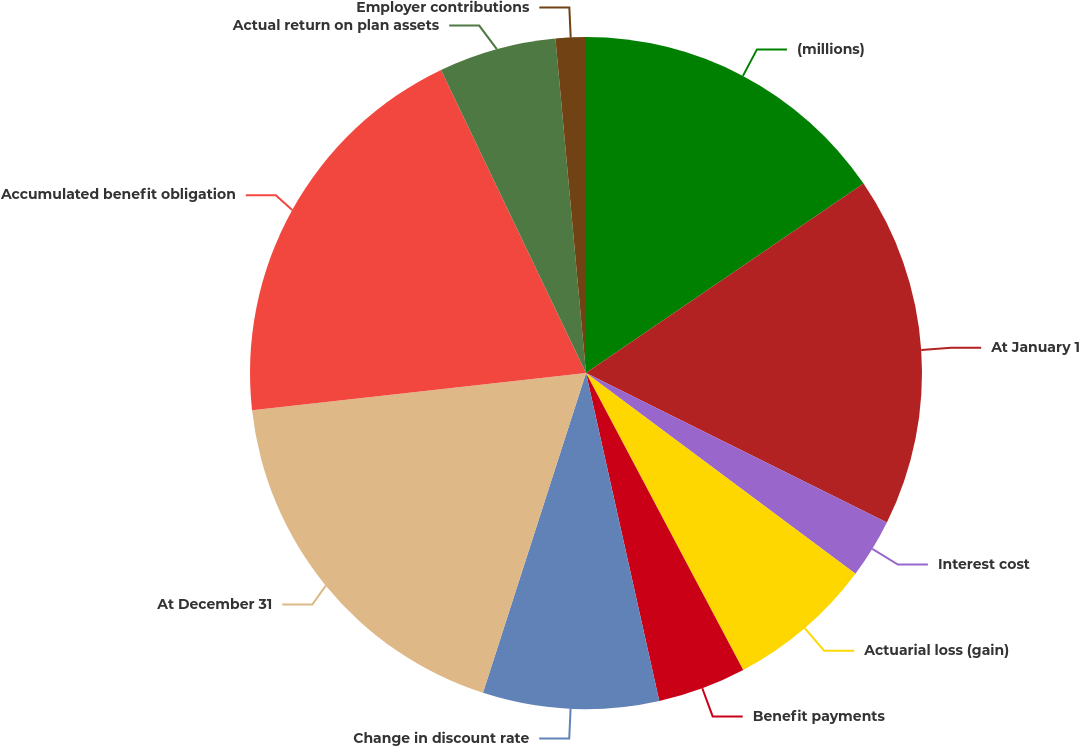Convert chart to OTSL. <chart><loc_0><loc_0><loc_500><loc_500><pie_chart><fcel>(millions)<fcel>At January 1<fcel>Interest cost<fcel>Actuarial loss (gain)<fcel>Benefit payments<fcel>Change in discount rate<fcel>At December 31<fcel>Accumulated benefit obligation<fcel>Actual return on plan assets<fcel>Employer contributions<nl><fcel>15.47%<fcel>16.87%<fcel>2.85%<fcel>7.06%<fcel>4.25%<fcel>8.46%<fcel>18.27%<fcel>19.67%<fcel>5.65%<fcel>1.45%<nl></chart> 